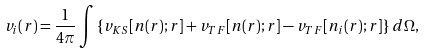<formula> <loc_0><loc_0><loc_500><loc_500>v _ { i } ( r ) = \frac { 1 } { 4 \pi } \int \left \{ v _ { K S } [ n ( { r } ) ; { r } ] + v _ { T F } [ n ( { r } ) ; { r } ] - v _ { T F } [ n _ { i } ( { r } ) ; { r } ] \right \} \, d \Omega ,</formula> 